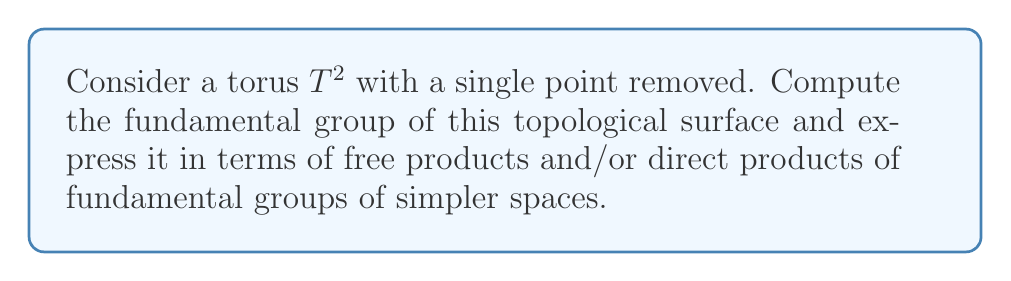Show me your answer to this math problem. To compute the fundamental group of a torus with a single point removed, let's approach this step-by-step:

1) First, recall that the fundamental group of a torus $T^2$ is:

   $$\pi_1(T^2) \cong \mathbb{Z} \times \mathbb{Z}$$

   This is because a torus can be represented as the product of two circles, and the fundamental group of a circle is $\mathbb{Z}$.

2) Now, removing a single point from a surface is topologically equivalent to removing an open disk. This operation is known as puncturing the surface.

3) When we puncture a surface, we're essentially adding a new generator to the fundamental group. This new generator corresponds to a loop around the puncture.

4) The fundamental group of a punctured surface can be expressed as the free product of the fundamental group of the original surface and the fundamental group of a circle:

   $$\pi_1(\text{punctured surface}) \cong \pi_1(\text{original surface}) * \mathbb{Z}$$

5) In our case, the original surface is a torus, so we have:

   $$\pi_1(T^2 \setminus \{\text{point}\}) \cong (\mathbb{Z} \times \mathbb{Z}) * \mathbb{Z}$$

6) This group can be interpreted as having three generators: two corresponding to the original torus (let's call them $a$ and $b$), and one corresponding to the puncture (let's call it $c$).

7) The generators $a$ and $b$ commute with each other (because they come from the direct product in the torus), but $c$ doesn't necessarily commute with $a$ or $b$.

Therefore, the fundamental group of a torus with a single point removed is the free product of $\mathbb{Z} \times \mathbb{Z}$ and $\mathbb{Z}$.
Answer: $$\pi_1(T^2 \setminus \{\text{point}\}) \cong (\mathbb{Z} \times \mathbb{Z}) * \mathbb{Z}$$ 